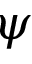Convert formula to latex. <formula><loc_0><loc_0><loc_500><loc_500>\psi</formula> 